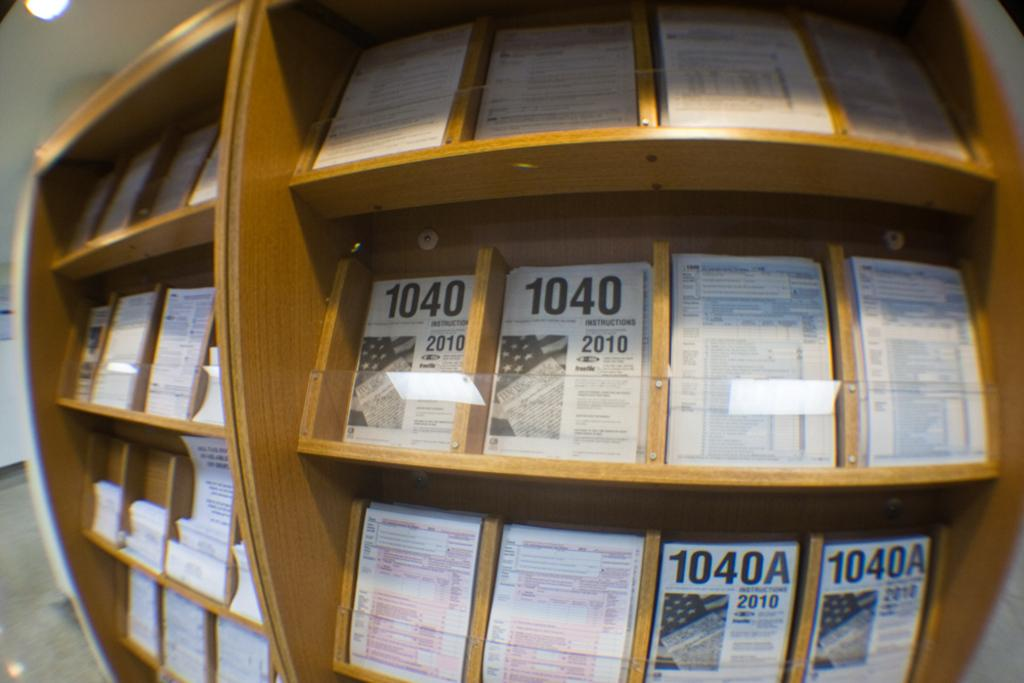<image>
Give a short and clear explanation of the subsequent image. Different 1040 forms for 2010 are neatly organized on bookshelves. 